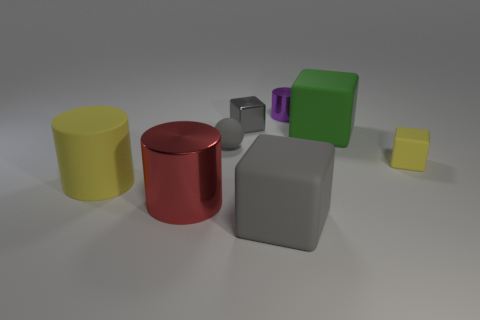How many things are shiny cubes or gray cubes?
Your answer should be very brief. 2. What is the size of the purple thing that is the same shape as the big red object?
Offer a terse response. Small. Are there any other things that are the same size as the gray metal cube?
Provide a short and direct response. Yes. What number of other objects are the same color as the metallic cube?
Your response must be concise. 2. What number of spheres are either big shiny things or big matte things?
Keep it short and to the point. 0. The big matte object that is in front of the metal cylinder that is in front of the gray metal object is what color?
Give a very brief answer. Gray. The purple shiny thing has what shape?
Ensure brevity in your answer.  Cylinder. There is a gray block in front of the red shiny object; does it have the same size as the yellow cylinder?
Offer a terse response. Yes. Is there another thing that has the same material as the tiny purple object?
Keep it short and to the point. Yes. What number of things are either big things on the right side of the gray ball or tiny cylinders?
Make the answer very short. 3. 